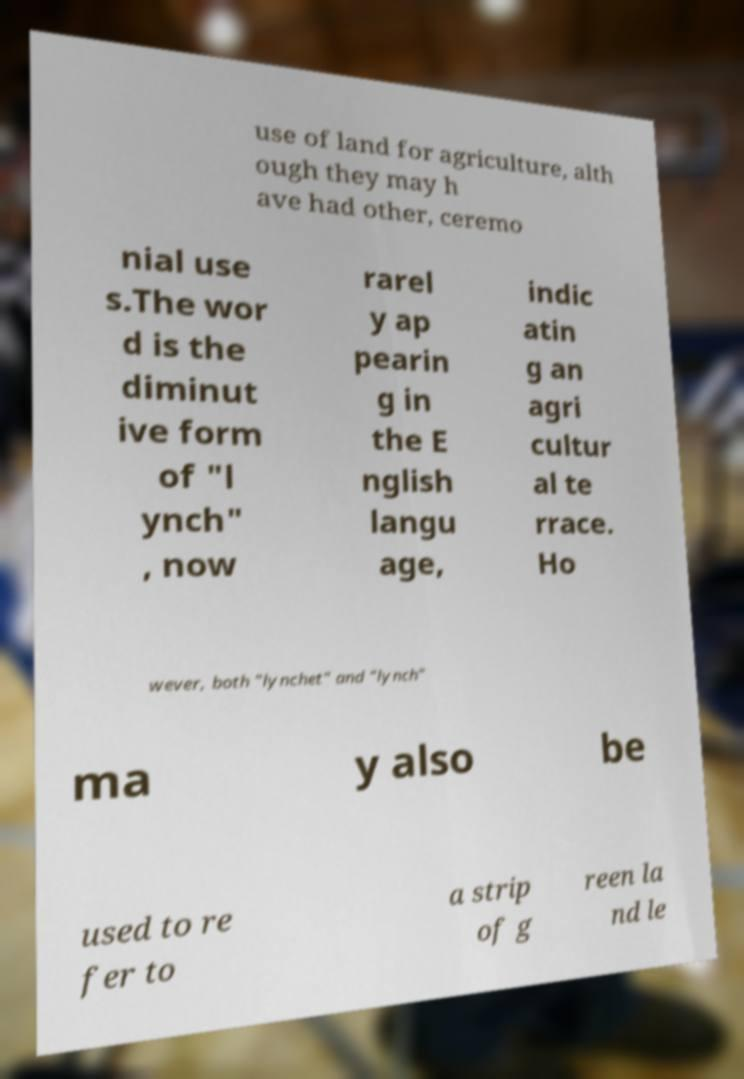Can you read and provide the text displayed in the image?This photo seems to have some interesting text. Can you extract and type it out for me? use of land for agriculture, alth ough they may h ave had other, ceremo nial use s.The wor d is the diminut ive form of "l ynch" , now rarel y ap pearin g in the E nglish langu age, indic atin g an agri cultur al te rrace. Ho wever, both "lynchet" and "lynch" ma y also be used to re fer to a strip of g reen la nd le 